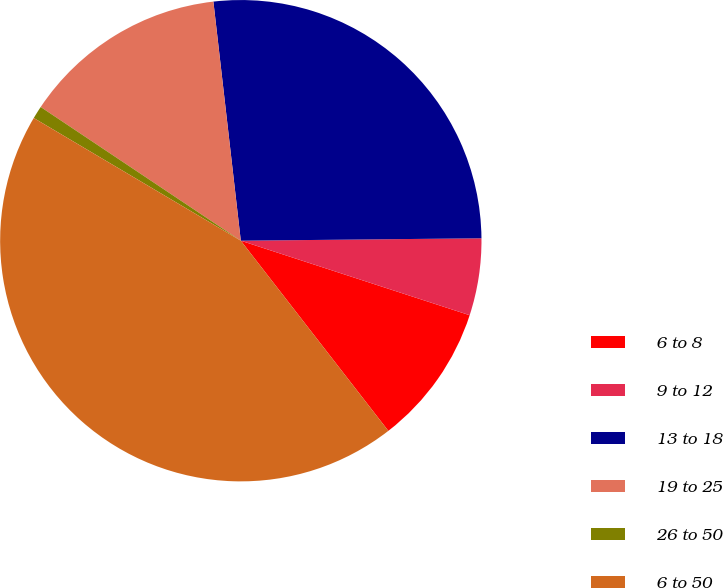<chart> <loc_0><loc_0><loc_500><loc_500><pie_chart><fcel>6 to 8<fcel>9 to 12<fcel>13 to 18<fcel>19 to 25<fcel>26 to 50<fcel>6 to 50<nl><fcel>9.49%<fcel>5.17%<fcel>26.66%<fcel>13.81%<fcel>0.86%<fcel>44.02%<nl></chart> 